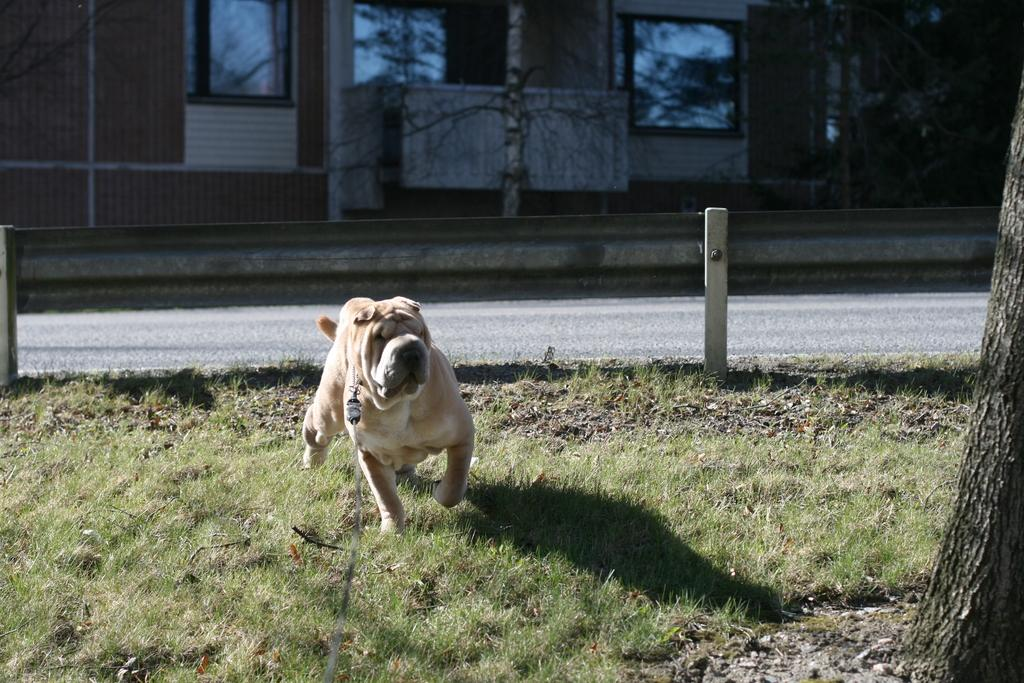What animal can be seen in the image? There is a dog in the image. What is the dog doing in the image? The dog is running in the grass. What type of structure is visible in the image? There is a house with windows in the image. Where is the house located in the image? The house is at the back side of the image. What can be seen in the middle of the image? There appears to be a road in the middle of the image. What type of stone is the dog using to attend class in the image? There is no stone or class present in the image; it features a dog running in the grass and a house with windows. 